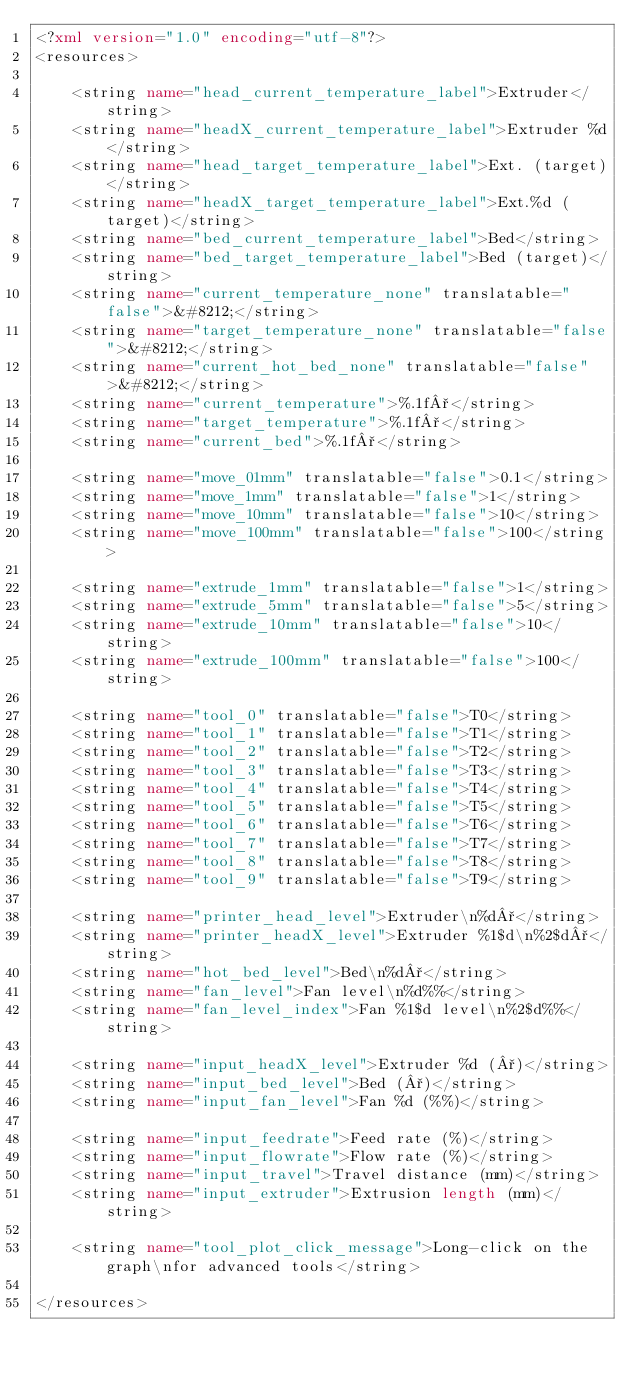<code> <loc_0><loc_0><loc_500><loc_500><_XML_><?xml version="1.0" encoding="utf-8"?>
<resources>

    <string name="head_current_temperature_label">Extruder</string>
    <string name="headX_current_temperature_label">Extruder %d</string>
    <string name="head_target_temperature_label">Ext. (target)</string>
    <string name="headX_target_temperature_label">Ext.%d (target)</string>
    <string name="bed_current_temperature_label">Bed</string>
    <string name="bed_target_temperature_label">Bed (target)</string>
    <string name="current_temperature_none" translatable="false">&#8212;</string>
    <string name="target_temperature_none" translatable="false">&#8212;</string>
    <string name="current_hot_bed_none" translatable="false">&#8212;</string>
    <string name="current_temperature">%.1f°</string>
    <string name="target_temperature">%.1f°</string>
    <string name="current_bed">%.1f°</string>

    <string name="move_01mm" translatable="false">0.1</string>
    <string name="move_1mm" translatable="false">1</string>
    <string name="move_10mm" translatable="false">10</string>
    <string name="move_100mm" translatable="false">100</string>

    <string name="extrude_1mm" translatable="false">1</string>
    <string name="extrude_5mm" translatable="false">5</string>
    <string name="extrude_10mm" translatable="false">10</string>
    <string name="extrude_100mm" translatable="false">100</string>

    <string name="tool_0" translatable="false">T0</string>
    <string name="tool_1" translatable="false">T1</string>
    <string name="tool_2" translatable="false">T2</string>
    <string name="tool_3" translatable="false">T3</string>
    <string name="tool_4" translatable="false">T4</string>
    <string name="tool_5" translatable="false">T5</string>
    <string name="tool_6" translatable="false">T6</string>
    <string name="tool_7" translatable="false">T7</string>
    <string name="tool_8" translatable="false">T8</string>
    <string name="tool_9" translatable="false">T9</string>

    <string name="printer_head_level">Extruder\n%d°</string>
    <string name="printer_headX_level">Extruder %1$d\n%2$d°</string>
    <string name="hot_bed_level">Bed\n%d°</string>
    <string name="fan_level">Fan level\n%d%%</string>
    <string name="fan_level_index">Fan %1$d level\n%2$d%%</string>

    <string name="input_headX_level">Extruder %d (°)</string>
    <string name="input_bed_level">Bed (°)</string>
    <string name="input_fan_level">Fan %d (%%)</string>

    <string name="input_feedrate">Feed rate (%)</string>
    <string name="input_flowrate">Flow rate (%)</string>
    <string name="input_travel">Travel distance (mm)</string>
    <string name="input_extruder">Extrusion length (mm)</string>

    <string name="tool_plot_click_message">Long-click on the graph\nfor advanced tools</string>

</resources></code> 